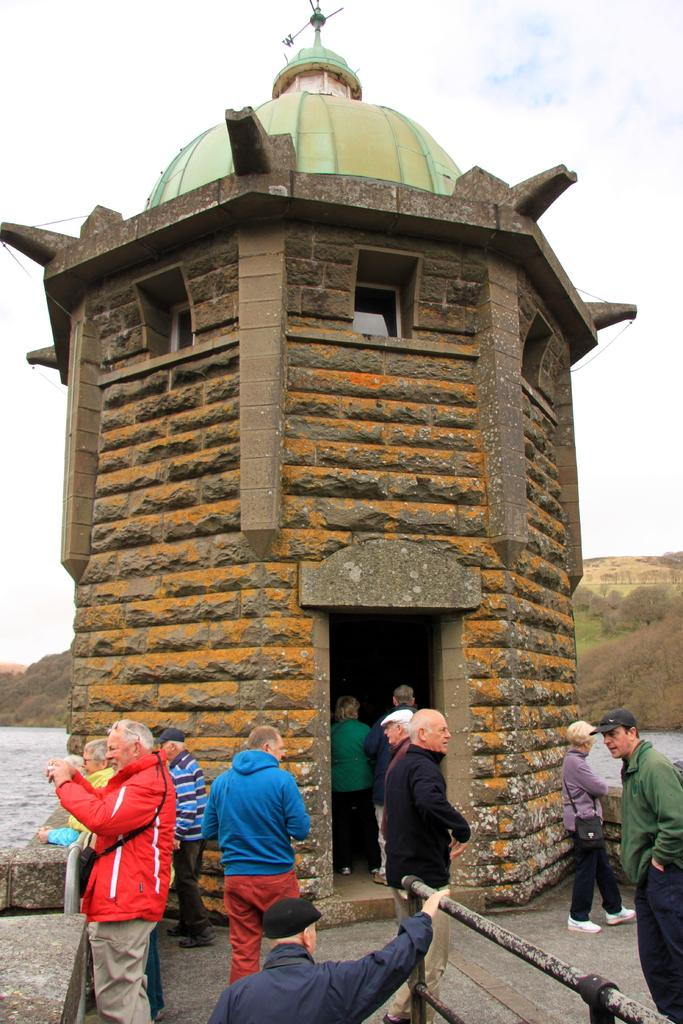What is the main subject in the center of the image? There is a tomb in the center of the image. Are there any other people or objects visible in the image? Yes, there are people at the bottom of the image. Where is the playground located in the image? There is no playground present in the image. What type of bottle can be seen near the tomb? There is no bottle visible in the image. 